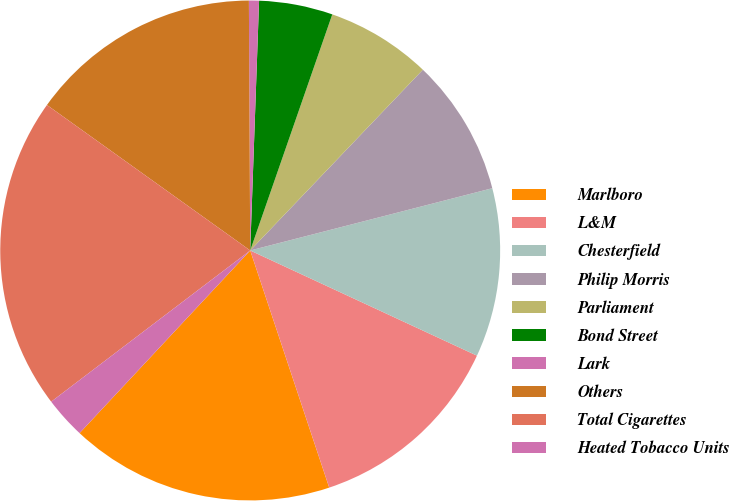Convert chart to OTSL. <chart><loc_0><loc_0><loc_500><loc_500><pie_chart><fcel>Marlboro<fcel>L&M<fcel>Chesterfield<fcel>Philip Morris<fcel>Parliament<fcel>Bond Street<fcel>Lark<fcel>Others<fcel>Total Cigarettes<fcel>Heated Tobacco Units<nl><fcel>17.08%<fcel>12.97%<fcel>10.92%<fcel>8.86%<fcel>6.81%<fcel>4.76%<fcel>0.65%<fcel>15.03%<fcel>20.23%<fcel>2.7%<nl></chart> 